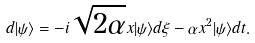Convert formula to latex. <formula><loc_0><loc_0><loc_500><loc_500>d | \psi \rangle = - i \sqrt { 2 \alpha } x | \psi \rangle d \xi - \alpha x ^ { 2 } | \psi \rangle d t .</formula> 